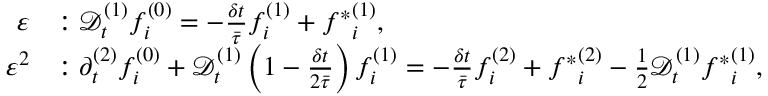Convert formula to latex. <formula><loc_0><loc_0><loc_500><loc_500>\begin{array} { r l } { \varepsilon } & { \colon \mathcal { D } _ { t } ^ { ( 1 ) } f _ { i } ^ { ( 0 ) } = - \frac { \delta t } { \bar { \tau } } f _ { i } ^ { ( 1 ) } + { f ^ { * } } _ { i } ^ { ( 1 ) } , } \\ { \varepsilon ^ { 2 } } & { \colon \partial _ { t } ^ { ( 2 ) } f _ { i } ^ { ( 0 ) } + \mathcal { D } _ { t } ^ { ( 1 ) } \left ( 1 - \frac { \delta t } { 2 \bar { \tau } } \right ) f _ { i } ^ { ( 1 ) } = - \frac { \delta t } { \bar { \tau } } f _ { i } ^ { ( 2 ) } + { f ^ { * } } _ { i } ^ { ( 2 ) } - \frac { 1 } { 2 } \mathcal { D } _ { t } ^ { ( 1 ) } { f ^ { * } } _ { i } ^ { ( 1 ) } , } \end{array}</formula> 